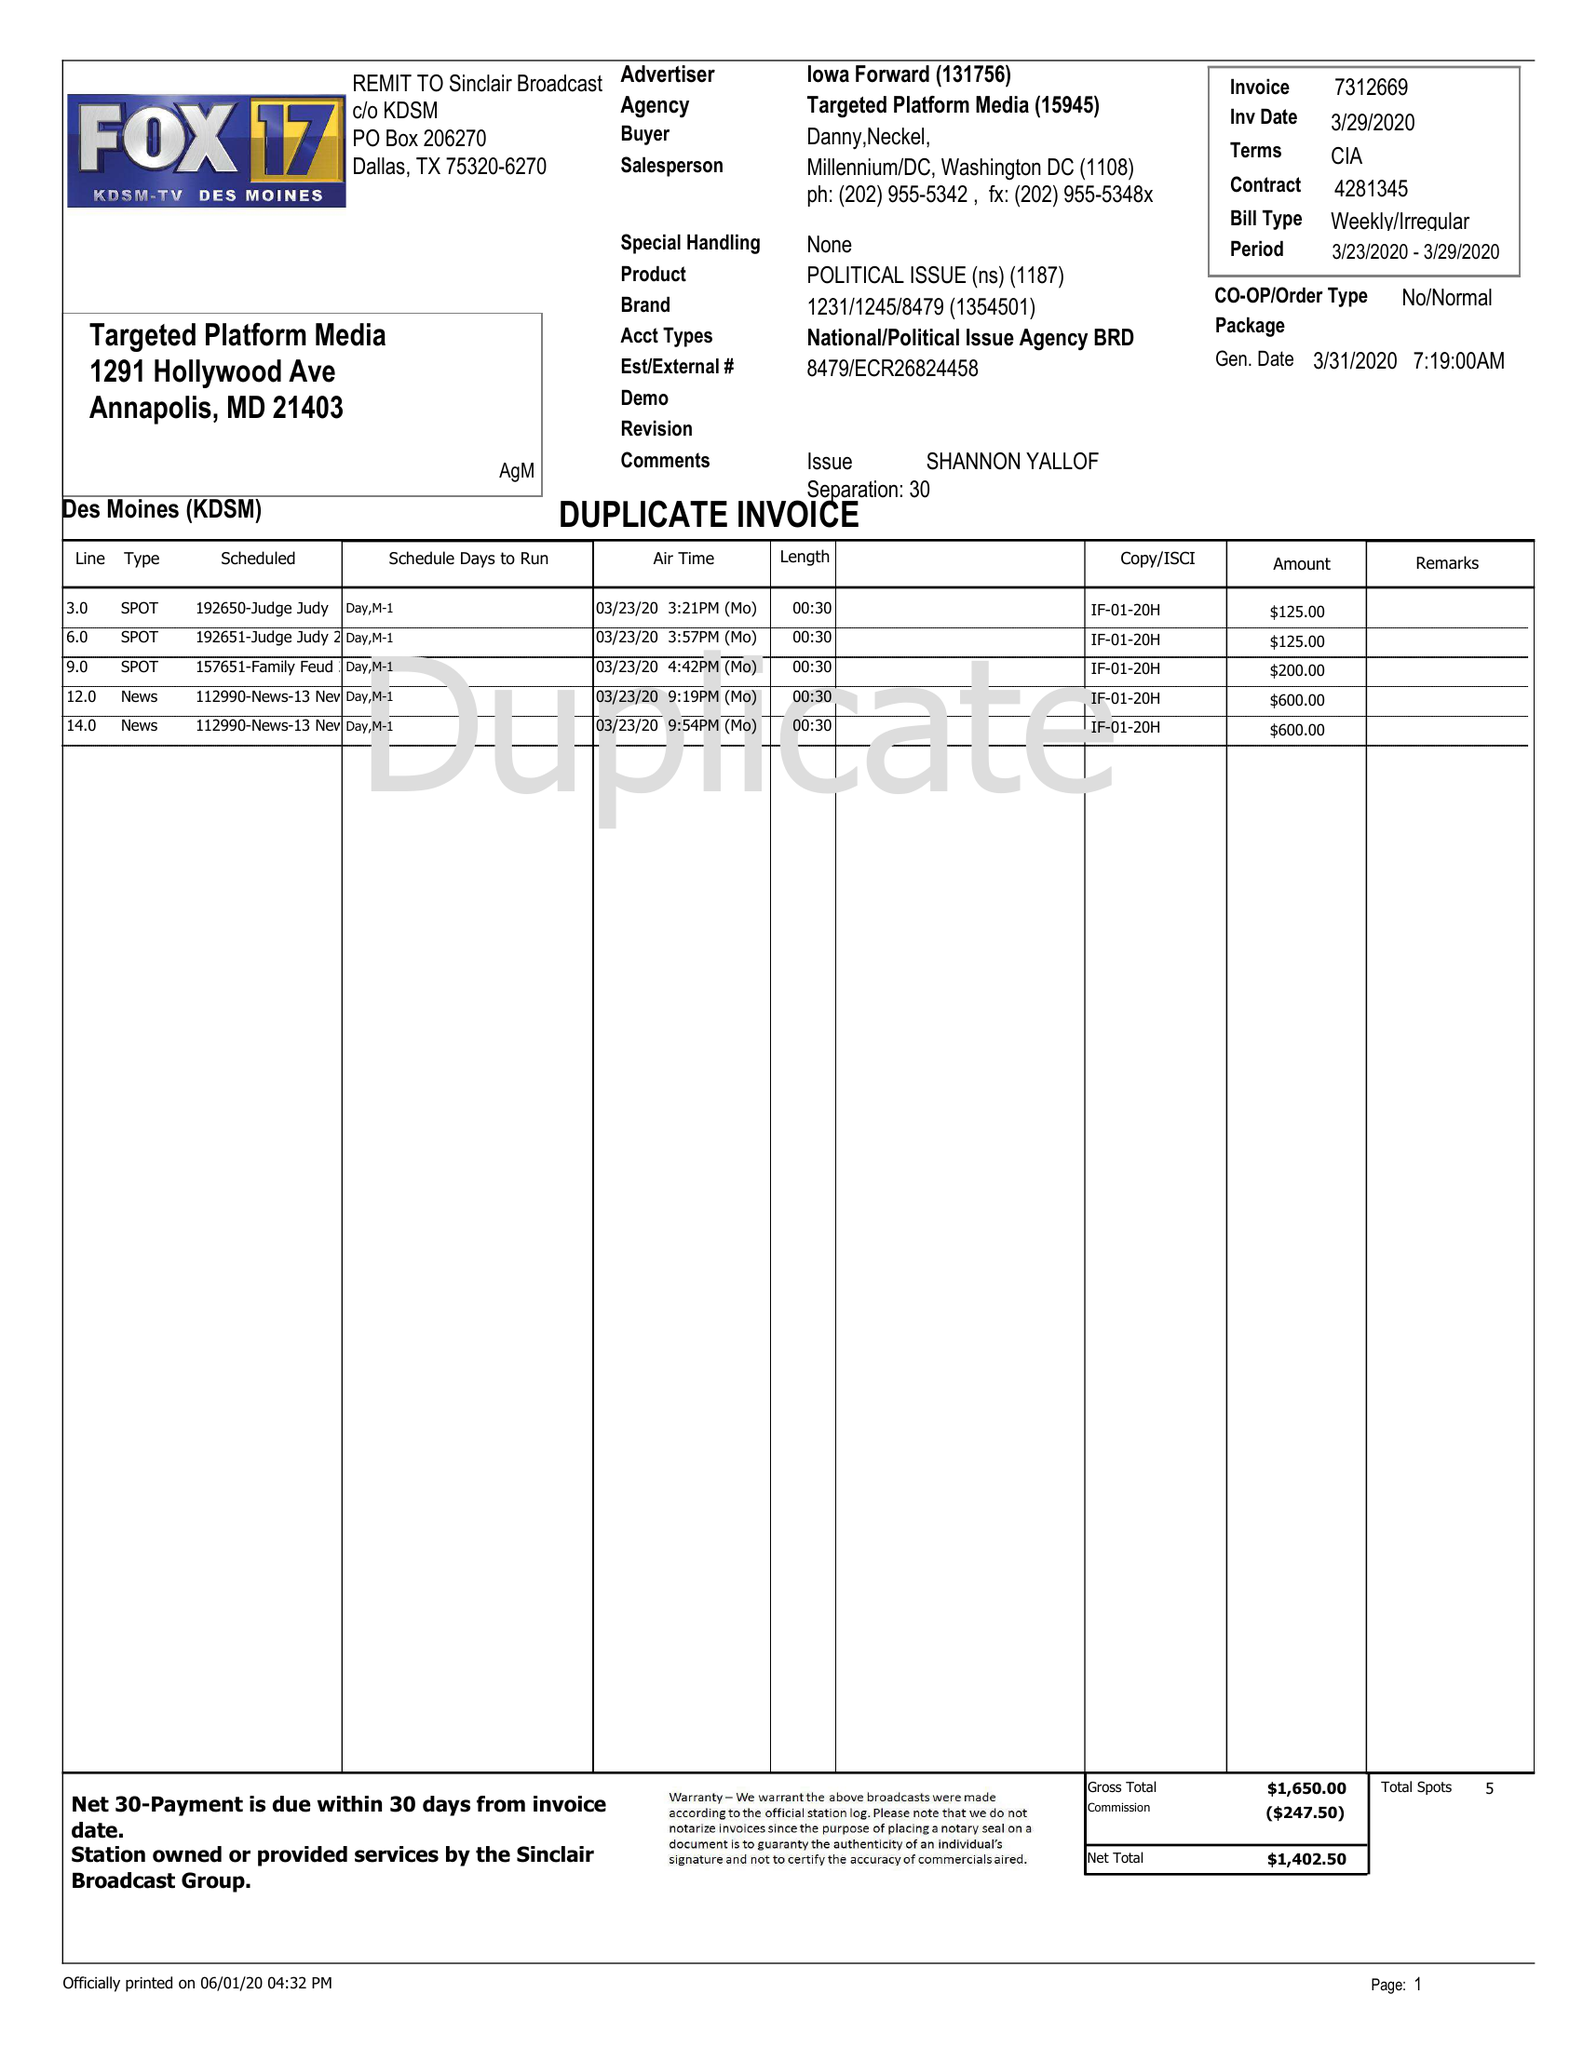What is the value for the gross_amount?
Answer the question using a single word or phrase. 1650.00 